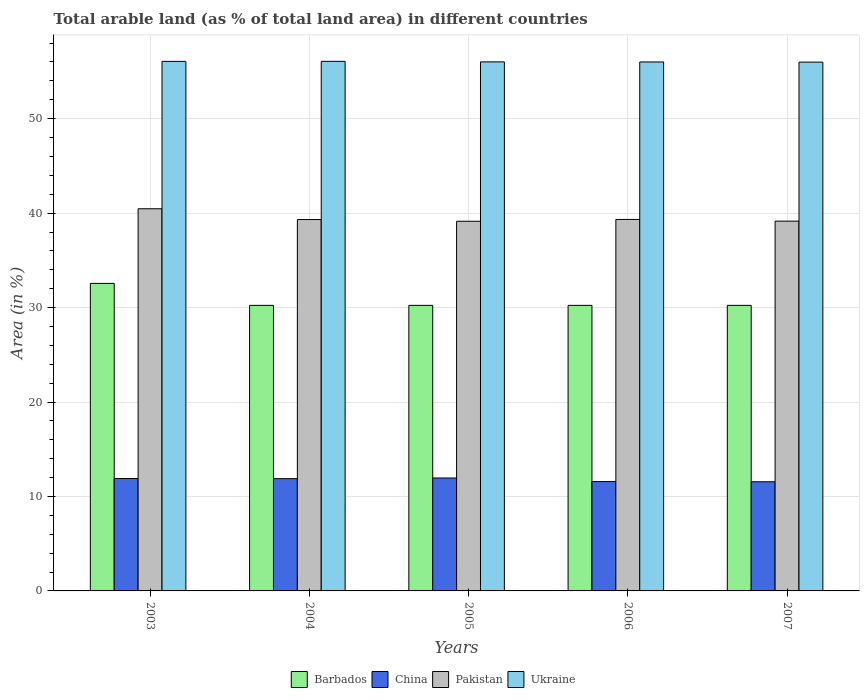How many different coloured bars are there?
Ensure brevity in your answer.  4. How many groups of bars are there?
Offer a terse response. 5. Are the number of bars on each tick of the X-axis equal?
Your response must be concise. Yes. What is the label of the 2nd group of bars from the left?
Your answer should be very brief. 2004. What is the percentage of arable land in Pakistan in 2006?
Ensure brevity in your answer.  39.33. Across all years, what is the maximum percentage of arable land in China?
Keep it short and to the point. 11.96. Across all years, what is the minimum percentage of arable land in Ukraine?
Provide a short and direct response. 55.99. In which year was the percentage of arable land in Pakistan maximum?
Ensure brevity in your answer.  2003. In which year was the percentage of arable land in Barbados minimum?
Provide a succinct answer. 2004. What is the total percentage of arable land in Pakistan in the graph?
Provide a succinct answer. 197.4. What is the difference between the percentage of arable land in China in 2003 and that in 2007?
Provide a short and direct response. 0.34. What is the difference between the percentage of arable land in Pakistan in 2007 and the percentage of arable land in Ukraine in 2003?
Provide a succinct answer. -16.91. What is the average percentage of arable land in Barbados per year?
Offer a very short reply. 30.7. In the year 2005, what is the difference between the percentage of arable land in Ukraine and percentage of arable land in Barbados?
Your answer should be compact. 25.78. In how many years, is the percentage of arable land in Barbados greater than 20 %?
Your answer should be compact. 5. What is the ratio of the percentage of arable land in Ukraine in 2004 to that in 2006?
Offer a very short reply. 1. Is the percentage of arable land in China in 2004 less than that in 2007?
Your answer should be compact. No. What is the difference between the highest and the second highest percentage of arable land in Barbados?
Offer a very short reply. 2.33. What is the difference between the highest and the lowest percentage of arable land in Barbados?
Your answer should be very brief. 2.33. Is the sum of the percentage of arable land in China in 2004 and 2005 greater than the maximum percentage of arable land in Ukraine across all years?
Keep it short and to the point. No. What does the 3rd bar from the left in 2006 represents?
Offer a terse response. Pakistan. Is it the case that in every year, the sum of the percentage of arable land in Pakistan and percentage of arable land in China is greater than the percentage of arable land in Barbados?
Give a very brief answer. Yes. How many bars are there?
Provide a short and direct response. 20. How many years are there in the graph?
Your answer should be compact. 5. Are the values on the major ticks of Y-axis written in scientific E-notation?
Ensure brevity in your answer.  No. Does the graph contain any zero values?
Keep it short and to the point. No. How are the legend labels stacked?
Your answer should be compact. Horizontal. What is the title of the graph?
Give a very brief answer. Total arable land (as % of total land area) in different countries. What is the label or title of the Y-axis?
Your answer should be compact. Area (in %). What is the Area (in %) in Barbados in 2003?
Make the answer very short. 32.56. What is the Area (in %) in China in 2003?
Provide a short and direct response. 11.9. What is the Area (in %) in Pakistan in 2003?
Provide a short and direct response. 40.46. What is the Area (in %) in Ukraine in 2003?
Your response must be concise. 56.06. What is the Area (in %) in Barbados in 2004?
Provide a succinct answer. 30.23. What is the Area (in %) in China in 2004?
Offer a very short reply. 11.89. What is the Area (in %) of Pakistan in 2004?
Offer a terse response. 39.32. What is the Area (in %) in Ukraine in 2004?
Provide a short and direct response. 56.07. What is the Area (in %) of Barbados in 2005?
Keep it short and to the point. 30.23. What is the Area (in %) in China in 2005?
Provide a short and direct response. 11.96. What is the Area (in %) of Pakistan in 2005?
Provide a succinct answer. 39.14. What is the Area (in %) in Ukraine in 2005?
Ensure brevity in your answer.  56.01. What is the Area (in %) of Barbados in 2006?
Give a very brief answer. 30.23. What is the Area (in %) of China in 2006?
Ensure brevity in your answer.  11.58. What is the Area (in %) of Pakistan in 2006?
Give a very brief answer. 39.33. What is the Area (in %) in Ukraine in 2006?
Provide a succinct answer. 56. What is the Area (in %) in Barbados in 2007?
Your answer should be compact. 30.23. What is the Area (in %) of China in 2007?
Your response must be concise. 11.56. What is the Area (in %) in Pakistan in 2007?
Give a very brief answer. 39.15. What is the Area (in %) of Ukraine in 2007?
Your answer should be very brief. 55.99. Across all years, what is the maximum Area (in %) in Barbados?
Provide a succinct answer. 32.56. Across all years, what is the maximum Area (in %) of China?
Make the answer very short. 11.96. Across all years, what is the maximum Area (in %) of Pakistan?
Provide a succinct answer. 40.46. Across all years, what is the maximum Area (in %) of Ukraine?
Keep it short and to the point. 56.07. Across all years, what is the minimum Area (in %) in Barbados?
Make the answer very short. 30.23. Across all years, what is the minimum Area (in %) in China?
Make the answer very short. 11.56. Across all years, what is the minimum Area (in %) of Pakistan?
Provide a short and direct response. 39.14. Across all years, what is the minimum Area (in %) in Ukraine?
Give a very brief answer. 55.99. What is the total Area (in %) of Barbados in the graph?
Give a very brief answer. 153.49. What is the total Area (in %) in China in the graph?
Your answer should be compact. 58.88. What is the total Area (in %) in Pakistan in the graph?
Ensure brevity in your answer.  197.4. What is the total Area (in %) of Ukraine in the graph?
Provide a succinct answer. 280.13. What is the difference between the Area (in %) of Barbados in 2003 and that in 2004?
Your answer should be compact. 2.33. What is the difference between the Area (in %) of China in 2003 and that in 2004?
Provide a succinct answer. 0.01. What is the difference between the Area (in %) in Pakistan in 2003 and that in 2004?
Offer a terse response. 1.14. What is the difference between the Area (in %) of Ukraine in 2003 and that in 2004?
Keep it short and to the point. -0. What is the difference between the Area (in %) in Barbados in 2003 and that in 2005?
Your answer should be compact. 2.33. What is the difference between the Area (in %) in China in 2003 and that in 2005?
Your response must be concise. -0.06. What is the difference between the Area (in %) of Pakistan in 2003 and that in 2005?
Make the answer very short. 1.32. What is the difference between the Area (in %) in Ukraine in 2003 and that in 2005?
Your answer should be compact. 0.05. What is the difference between the Area (in %) of Barbados in 2003 and that in 2006?
Offer a terse response. 2.33. What is the difference between the Area (in %) of China in 2003 and that in 2006?
Provide a short and direct response. 0.32. What is the difference between the Area (in %) in Pakistan in 2003 and that in 2006?
Offer a terse response. 1.13. What is the difference between the Area (in %) in Ukraine in 2003 and that in 2006?
Offer a terse response. 0.06. What is the difference between the Area (in %) in Barbados in 2003 and that in 2007?
Give a very brief answer. 2.33. What is the difference between the Area (in %) in China in 2003 and that in 2007?
Keep it short and to the point. 0.34. What is the difference between the Area (in %) in Pakistan in 2003 and that in 2007?
Your answer should be compact. 1.31. What is the difference between the Area (in %) of Ukraine in 2003 and that in 2007?
Your answer should be very brief. 0.08. What is the difference between the Area (in %) of China in 2004 and that in 2005?
Your answer should be very brief. -0.07. What is the difference between the Area (in %) of Pakistan in 2004 and that in 2005?
Offer a terse response. 0.18. What is the difference between the Area (in %) of Ukraine in 2004 and that in 2005?
Ensure brevity in your answer.  0.06. What is the difference between the Area (in %) of Barbados in 2004 and that in 2006?
Offer a very short reply. 0. What is the difference between the Area (in %) of China in 2004 and that in 2006?
Your answer should be very brief. 0.31. What is the difference between the Area (in %) in Pakistan in 2004 and that in 2006?
Offer a very short reply. -0.01. What is the difference between the Area (in %) of Ukraine in 2004 and that in 2006?
Make the answer very short. 0.06. What is the difference between the Area (in %) of Barbados in 2004 and that in 2007?
Provide a short and direct response. 0. What is the difference between the Area (in %) in China in 2004 and that in 2007?
Your answer should be compact. 0.33. What is the difference between the Area (in %) in Pakistan in 2004 and that in 2007?
Make the answer very short. 0.17. What is the difference between the Area (in %) in Ukraine in 2004 and that in 2007?
Give a very brief answer. 0.08. What is the difference between the Area (in %) of China in 2005 and that in 2006?
Give a very brief answer. 0.38. What is the difference between the Area (in %) in Pakistan in 2005 and that in 2006?
Keep it short and to the point. -0.19. What is the difference between the Area (in %) in Ukraine in 2005 and that in 2006?
Offer a terse response. 0.01. What is the difference between the Area (in %) in China in 2005 and that in 2007?
Offer a terse response. 0.4. What is the difference between the Area (in %) in Pakistan in 2005 and that in 2007?
Keep it short and to the point. -0.01. What is the difference between the Area (in %) of Ukraine in 2005 and that in 2007?
Make the answer very short. 0.03. What is the difference between the Area (in %) in China in 2006 and that in 2007?
Your answer should be compact. 0.02. What is the difference between the Area (in %) of Pakistan in 2006 and that in 2007?
Your answer should be very brief. 0.18. What is the difference between the Area (in %) in Ukraine in 2006 and that in 2007?
Your answer should be very brief. 0.02. What is the difference between the Area (in %) in Barbados in 2003 and the Area (in %) in China in 2004?
Offer a terse response. 20.67. What is the difference between the Area (in %) in Barbados in 2003 and the Area (in %) in Pakistan in 2004?
Give a very brief answer. -6.76. What is the difference between the Area (in %) of Barbados in 2003 and the Area (in %) of Ukraine in 2004?
Your answer should be compact. -23.51. What is the difference between the Area (in %) of China in 2003 and the Area (in %) of Pakistan in 2004?
Keep it short and to the point. -27.42. What is the difference between the Area (in %) in China in 2003 and the Area (in %) in Ukraine in 2004?
Give a very brief answer. -44.17. What is the difference between the Area (in %) of Pakistan in 2003 and the Area (in %) of Ukraine in 2004?
Make the answer very short. -15.61. What is the difference between the Area (in %) of Barbados in 2003 and the Area (in %) of China in 2005?
Keep it short and to the point. 20.6. What is the difference between the Area (in %) of Barbados in 2003 and the Area (in %) of Pakistan in 2005?
Your answer should be compact. -6.58. What is the difference between the Area (in %) of Barbados in 2003 and the Area (in %) of Ukraine in 2005?
Your response must be concise. -23.45. What is the difference between the Area (in %) of China in 2003 and the Area (in %) of Pakistan in 2005?
Make the answer very short. -27.24. What is the difference between the Area (in %) of China in 2003 and the Area (in %) of Ukraine in 2005?
Give a very brief answer. -44.11. What is the difference between the Area (in %) in Pakistan in 2003 and the Area (in %) in Ukraine in 2005?
Ensure brevity in your answer.  -15.55. What is the difference between the Area (in %) of Barbados in 2003 and the Area (in %) of China in 2006?
Your response must be concise. 20.98. What is the difference between the Area (in %) in Barbados in 2003 and the Area (in %) in Pakistan in 2006?
Offer a very short reply. -6.77. What is the difference between the Area (in %) in Barbados in 2003 and the Area (in %) in Ukraine in 2006?
Give a very brief answer. -23.45. What is the difference between the Area (in %) in China in 2003 and the Area (in %) in Pakistan in 2006?
Offer a very short reply. -27.43. What is the difference between the Area (in %) in China in 2003 and the Area (in %) in Ukraine in 2006?
Keep it short and to the point. -44.11. What is the difference between the Area (in %) of Pakistan in 2003 and the Area (in %) of Ukraine in 2006?
Offer a very short reply. -15.54. What is the difference between the Area (in %) in Barbados in 2003 and the Area (in %) in China in 2007?
Your answer should be compact. 21. What is the difference between the Area (in %) of Barbados in 2003 and the Area (in %) of Pakistan in 2007?
Provide a short and direct response. -6.59. What is the difference between the Area (in %) of Barbados in 2003 and the Area (in %) of Ukraine in 2007?
Provide a succinct answer. -23.43. What is the difference between the Area (in %) in China in 2003 and the Area (in %) in Pakistan in 2007?
Your response must be concise. -27.25. What is the difference between the Area (in %) of China in 2003 and the Area (in %) of Ukraine in 2007?
Make the answer very short. -44.09. What is the difference between the Area (in %) of Pakistan in 2003 and the Area (in %) of Ukraine in 2007?
Ensure brevity in your answer.  -15.53. What is the difference between the Area (in %) of Barbados in 2004 and the Area (in %) of China in 2005?
Provide a succinct answer. 18.28. What is the difference between the Area (in %) of Barbados in 2004 and the Area (in %) of Pakistan in 2005?
Offer a terse response. -8.9. What is the difference between the Area (in %) in Barbados in 2004 and the Area (in %) in Ukraine in 2005?
Your answer should be very brief. -25.78. What is the difference between the Area (in %) of China in 2004 and the Area (in %) of Pakistan in 2005?
Your answer should be compact. -27.25. What is the difference between the Area (in %) in China in 2004 and the Area (in %) in Ukraine in 2005?
Your response must be concise. -44.12. What is the difference between the Area (in %) in Pakistan in 2004 and the Area (in %) in Ukraine in 2005?
Provide a succinct answer. -16.69. What is the difference between the Area (in %) in Barbados in 2004 and the Area (in %) in China in 2006?
Give a very brief answer. 18.65. What is the difference between the Area (in %) in Barbados in 2004 and the Area (in %) in Pakistan in 2006?
Your answer should be compact. -9.1. What is the difference between the Area (in %) of Barbados in 2004 and the Area (in %) of Ukraine in 2006?
Keep it short and to the point. -25.77. What is the difference between the Area (in %) in China in 2004 and the Area (in %) in Pakistan in 2006?
Make the answer very short. -27.44. What is the difference between the Area (in %) of China in 2004 and the Area (in %) of Ukraine in 2006?
Offer a terse response. -44.12. What is the difference between the Area (in %) of Pakistan in 2004 and the Area (in %) of Ukraine in 2006?
Make the answer very short. -16.68. What is the difference between the Area (in %) of Barbados in 2004 and the Area (in %) of China in 2007?
Your answer should be compact. 18.68. What is the difference between the Area (in %) in Barbados in 2004 and the Area (in %) in Pakistan in 2007?
Provide a short and direct response. -8.92. What is the difference between the Area (in %) in Barbados in 2004 and the Area (in %) in Ukraine in 2007?
Provide a succinct answer. -25.75. What is the difference between the Area (in %) in China in 2004 and the Area (in %) in Pakistan in 2007?
Your response must be concise. -27.26. What is the difference between the Area (in %) of China in 2004 and the Area (in %) of Ukraine in 2007?
Offer a very short reply. -44.1. What is the difference between the Area (in %) of Pakistan in 2004 and the Area (in %) of Ukraine in 2007?
Give a very brief answer. -16.67. What is the difference between the Area (in %) of Barbados in 2005 and the Area (in %) of China in 2006?
Provide a short and direct response. 18.65. What is the difference between the Area (in %) in Barbados in 2005 and the Area (in %) in Pakistan in 2006?
Your answer should be compact. -9.1. What is the difference between the Area (in %) of Barbados in 2005 and the Area (in %) of Ukraine in 2006?
Give a very brief answer. -25.77. What is the difference between the Area (in %) in China in 2005 and the Area (in %) in Pakistan in 2006?
Keep it short and to the point. -27.38. What is the difference between the Area (in %) in China in 2005 and the Area (in %) in Ukraine in 2006?
Your response must be concise. -44.05. What is the difference between the Area (in %) in Pakistan in 2005 and the Area (in %) in Ukraine in 2006?
Keep it short and to the point. -16.87. What is the difference between the Area (in %) of Barbados in 2005 and the Area (in %) of China in 2007?
Offer a terse response. 18.68. What is the difference between the Area (in %) in Barbados in 2005 and the Area (in %) in Pakistan in 2007?
Your answer should be compact. -8.92. What is the difference between the Area (in %) in Barbados in 2005 and the Area (in %) in Ukraine in 2007?
Your answer should be compact. -25.75. What is the difference between the Area (in %) of China in 2005 and the Area (in %) of Pakistan in 2007?
Provide a succinct answer. -27.19. What is the difference between the Area (in %) of China in 2005 and the Area (in %) of Ukraine in 2007?
Ensure brevity in your answer.  -44.03. What is the difference between the Area (in %) of Pakistan in 2005 and the Area (in %) of Ukraine in 2007?
Provide a short and direct response. -16.85. What is the difference between the Area (in %) of Barbados in 2006 and the Area (in %) of China in 2007?
Provide a succinct answer. 18.68. What is the difference between the Area (in %) of Barbados in 2006 and the Area (in %) of Pakistan in 2007?
Your answer should be very brief. -8.92. What is the difference between the Area (in %) in Barbados in 2006 and the Area (in %) in Ukraine in 2007?
Offer a very short reply. -25.75. What is the difference between the Area (in %) in China in 2006 and the Area (in %) in Pakistan in 2007?
Ensure brevity in your answer.  -27.57. What is the difference between the Area (in %) of China in 2006 and the Area (in %) of Ukraine in 2007?
Provide a succinct answer. -44.41. What is the difference between the Area (in %) of Pakistan in 2006 and the Area (in %) of Ukraine in 2007?
Offer a very short reply. -16.65. What is the average Area (in %) of Barbados per year?
Make the answer very short. 30.7. What is the average Area (in %) of China per year?
Offer a very short reply. 11.78. What is the average Area (in %) of Pakistan per year?
Your response must be concise. 39.48. What is the average Area (in %) in Ukraine per year?
Offer a very short reply. 56.03. In the year 2003, what is the difference between the Area (in %) of Barbados and Area (in %) of China?
Offer a terse response. 20.66. In the year 2003, what is the difference between the Area (in %) in Barbados and Area (in %) in Pakistan?
Provide a short and direct response. -7.9. In the year 2003, what is the difference between the Area (in %) in Barbados and Area (in %) in Ukraine?
Give a very brief answer. -23.51. In the year 2003, what is the difference between the Area (in %) in China and Area (in %) in Pakistan?
Your answer should be very brief. -28.56. In the year 2003, what is the difference between the Area (in %) of China and Area (in %) of Ukraine?
Your answer should be very brief. -44.17. In the year 2003, what is the difference between the Area (in %) of Pakistan and Area (in %) of Ukraine?
Your response must be concise. -15.6. In the year 2004, what is the difference between the Area (in %) of Barbados and Area (in %) of China?
Keep it short and to the point. 18.35. In the year 2004, what is the difference between the Area (in %) in Barbados and Area (in %) in Pakistan?
Make the answer very short. -9.09. In the year 2004, what is the difference between the Area (in %) in Barbados and Area (in %) in Ukraine?
Ensure brevity in your answer.  -25.83. In the year 2004, what is the difference between the Area (in %) in China and Area (in %) in Pakistan?
Your answer should be very brief. -27.43. In the year 2004, what is the difference between the Area (in %) in China and Area (in %) in Ukraine?
Give a very brief answer. -44.18. In the year 2004, what is the difference between the Area (in %) of Pakistan and Area (in %) of Ukraine?
Make the answer very short. -16.75. In the year 2005, what is the difference between the Area (in %) of Barbados and Area (in %) of China?
Your response must be concise. 18.28. In the year 2005, what is the difference between the Area (in %) of Barbados and Area (in %) of Pakistan?
Offer a very short reply. -8.9. In the year 2005, what is the difference between the Area (in %) in Barbados and Area (in %) in Ukraine?
Provide a succinct answer. -25.78. In the year 2005, what is the difference between the Area (in %) of China and Area (in %) of Pakistan?
Keep it short and to the point. -27.18. In the year 2005, what is the difference between the Area (in %) of China and Area (in %) of Ukraine?
Provide a short and direct response. -44.06. In the year 2005, what is the difference between the Area (in %) of Pakistan and Area (in %) of Ukraine?
Your response must be concise. -16.87. In the year 2006, what is the difference between the Area (in %) in Barbados and Area (in %) in China?
Keep it short and to the point. 18.65. In the year 2006, what is the difference between the Area (in %) of Barbados and Area (in %) of Pakistan?
Give a very brief answer. -9.1. In the year 2006, what is the difference between the Area (in %) of Barbados and Area (in %) of Ukraine?
Offer a very short reply. -25.77. In the year 2006, what is the difference between the Area (in %) of China and Area (in %) of Pakistan?
Keep it short and to the point. -27.75. In the year 2006, what is the difference between the Area (in %) in China and Area (in %) in Ukraine?
Provide a short and direct response. -44.42. In the year 2006, what is the difference between the Area (in %) of Pakistan and Area (in %) of Ukraine?
Make the answer very short. -16.67. In the year 2007, what is the difference between the Area (in %) in Barbados and Area (in %) in China?
Provide a succinct answer. 18.68. In the year 2007, what is the difference between the Area (in %) in Barbados and Area (in %) in Pakistan?
Provide a succinct answer. -8.92. In the year 2007, what is the difference between the Area (in %) of Barbados and Area (in %) of Ukraine?
Provide a short and direct response. -25.75. In the year 2007, what is the difference between the Area (in %) of China and Area (in %) of Pakistan?
Your answer should be compact. -27.59. In the year 2007, what is the difference between the Area (in %) in China and Area (in %) in Ukraine?
Ensure brevity in your answer.  -44.43. In the year 2007, what is the difference between the Area (in %) of Pakistan and Area (in %) of Ukraine?
Your response must be concise. -16.84. What is the ratio of the Area (in %) in China in 2003 to that in 2004?
Your response must be concise. 1. What is the ratio of the Area (in %) in Pakistan in 2003 to that in 2004?
Make the answer very short. 1.03. What is the ratio of the Area (in %) of Barbados in 2003 to that in 2005?
Give a very brief answer. 1.08. What is the ratio of the Area (in %) of China in 2003 to that in 2005?
Your answer should be compact. 1. What is the ratio of the Area (in %) in Pakistan in 2003 to that in 2005?
Offer a very short reply. 1.03. What is the ratio of the Area (in %) in Ukraine in 2003 to that in 2005?
Provide a succinct answer. 1. What is the ratio of the Area (in %) of China in 2003 to that in 2006?
Your answer should be very brief. 1.03. What is the ratio of the Area (in %) in Pakistan in 2003 to that in 2006?
Your answer should be very brief. 1.03. What is the ratio of the Area (in %) of China in 2003 to that in 2007?
Your response must be concise. 1.03. What is the ratio of the Area (in %) of Pakistan in 2003 to that in 2007?
Offer a terse response. 1.03. What is the ratio of the Area (in %) in China in 2004 to that in 2005?
Your answer should be very brief. 0.99. What is the ratio of the Area (in %) in Barbados in 2004 to that in 2006?
Ensure brevity in your answer.  1. What is the ratio of the Area (in %) of China in 2004 to that in 2006?
Your answer should be very brief. 1.03. What is the ratio of the Area (in %) of Pakistan in 2004 to that in 2006?
Your answer should be compact. 1. What is the ratio of the Area (in %) in China in 2004 to that in 2007?
Offer a very short reply. 1.03. What is the ratio of the Area (in %) in China in 2005 to that in 2006?
Provide a short and direct response. 1.03. What is the ratio of the Area (in %) of China in 2005 to that in 2007?
Make the answer very short. 1.03. What is the ratio of the Area (in %) of Pakistan in 2005 to that in 2007?
Give a very brief answer. 1. What is the ratio of the Area (in %) in China in 2006 to that in 2007?
Provide a succinct answer. 1. What is the ratio of the Area (in %) of Ukraine in 2006 to that in 2007?
Your answer should be compact. 1. What is the difference between the highest and the second highest Area (in %) of Barbados?
Your response must be concise. 2.33. What is the difference between the highest and the second highest Area (in %) in China?
Provide a succinct answer. 0.06. What is the difference between the highest and the second highest Area (in %) of Pakistan?
Your answer should be compact. 1.13. What is the difference between the highest and the second highest Area (in %) of Ukraine?
Keep it short and to the point. 0. What is the difference between the highest and the lowest Area (in %) of Barbados?
Provide a short and direct response. 2.33. What is the difference between the highest and the lowest Area (in %) in China?
Offer a terse response. 0.4. What is the difference between the highest and the lowest Area (in %) of Pakistan?
Make the answer very short. 1.32. What is the difference between the highest and the lowest Area (in %) in Ukraine?
Give a very brief answer. 0.08. 